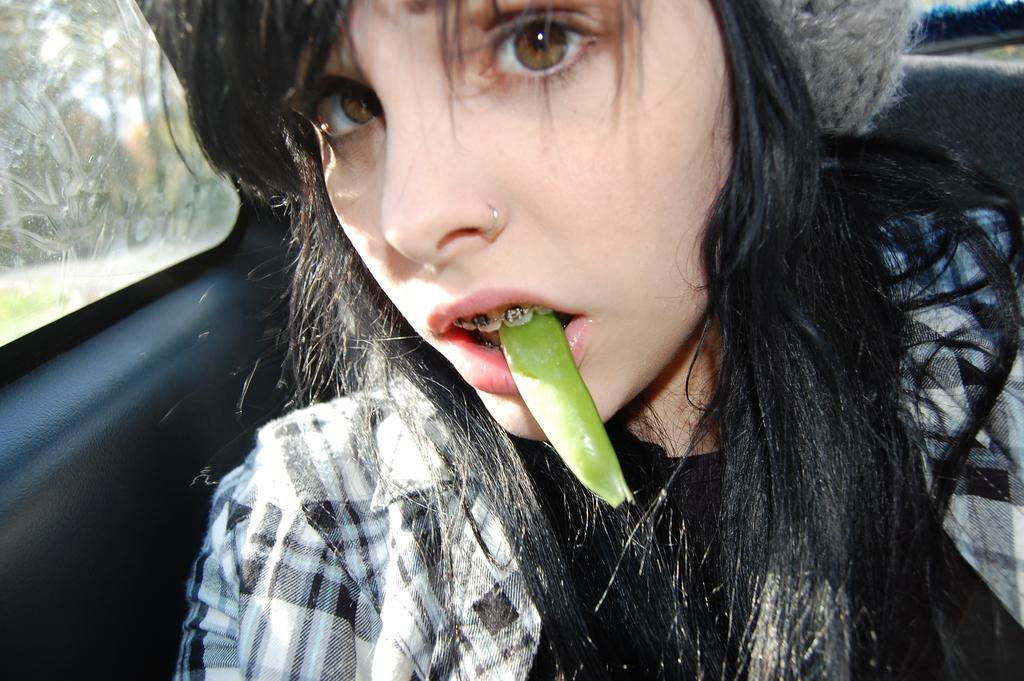What is the main subject of the image? The main subject of the image is a girl in a vehicle. What is the girl doing in the image? The girl has a green color object in her mouth. What can be seen in the background of the image? There are trees visible in the background of the image. What type of respect can be seen being shown to the sand in the image? There is no sand present in the image, so it is not possible to determine if any respect is being shown to it. 